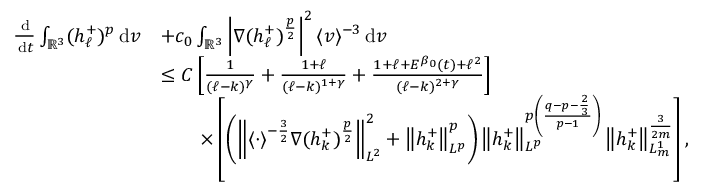Convert formula to latex. <formula><loc_0><loc_0><loc_500><loc_500>\begin{array} { r l } { \frac { \, d } { \, d t } \int _ { { \mathbb { R } } ^ { 3 } } ( h _ { \ell } ^ { + } ) ^ { p } \, d v } & { + c _ { 0 } \int _ { { \mathbb { R } } ^ { 3 } } \left | \nabla ( h _ { \ell } ^ { + } ) ^ { \frac { p } { 2 } } \right | ^ { 2 } \langle v \rangle ^ { - 3 } \, d v } \\ & { \leq C \left [ \frac { 1 } { ( \ell - k ) ^ { \gamma } } + \frac { 1 + \ell } { ( \ell - k ) ^ { 1 + \gamma } } + \frac { 1 + \ell + E ^ { \beta _ { 0 } } ( t ) + \ell ^ { 2 } } { ( \ell - k ) ^ { 2 + \gamma } } \right ] } \\ & { \quad \times \left [ \left ( \left \| \langle \cdot \rangle ^ { - \frac { 3 } { 2 } } \nabla ( h _ { k } ^ { + } ) ^ { \frac { p } { 2 } } \right \| _ { L ^ { 2 } } ^ { 2 } + \left \| h _ { k } ^ { + } \right \| _ { L ^ { p } } ^ { p } \right ) \left \| h _ { k } ^ { + } \right \| _ { L ^ { p } } ^ { p \left ( \frac { q - p - \frac { 2 } { 3 } } { p - 1 } \right ) } \left \| h _ { k } ^ { + } \right \| _ { L _ { m } ^ { 1 } } ^ { \frac { 3 } { 2 m } } \right ] , } \end{array}</formula> 